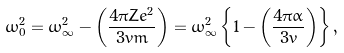<formula> <loc_0><loc_0><loc_500><loc_500>\omega _ { 0 } ^ { 2 } = \omega _ { \infty } ^ { 2 } - \left ( \frac { 4 \pi Z e ^ { 2 } } { 3 v m } \right ) = \omega _ { \infty } ^ { 2 } \left \{ 1 - \left ( \frac { 4 \pi \alpha } { 3 v } \right ) \right \} ,</formula> 